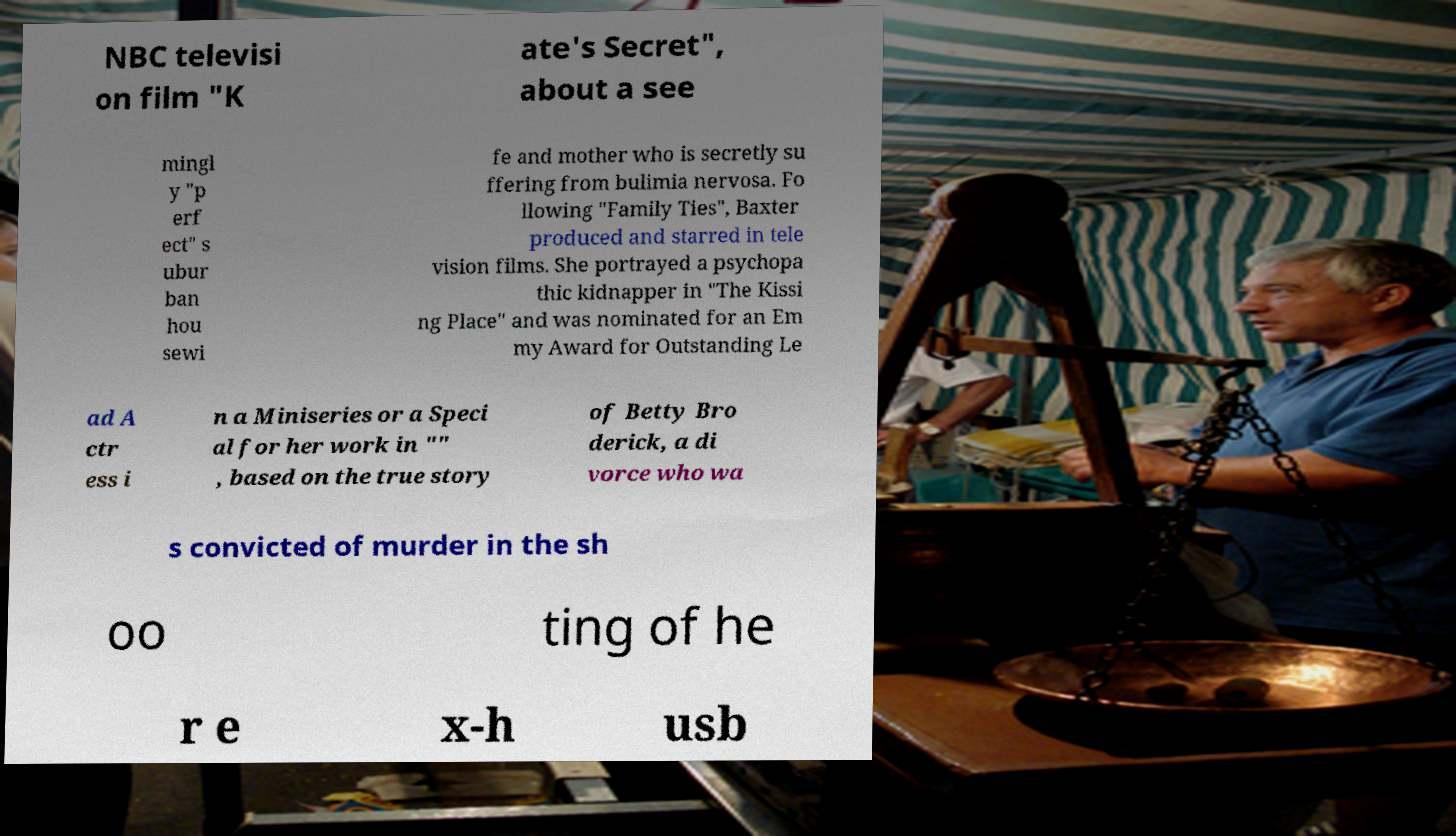I need the written content from this picture converted into text. Can you do that? NBC televisi on film "K ate's Secret", about a see mingl y "p erf ect" s ubur ban hou sewi fe and mother who is secretly su ffering from bulimia nervosa. Fo llowing "Family Ties", Baxter produced and starred in tele vision films. She portrayed a psychopa thic kidnapper in "The Kissi ng Place" and was nominated for an Em my Award for Outstanding Le ad A ctr ess i n a Miniseries or a Speci al for her work in "" , based on the true story of Betty Bro derick, a di vorce who wa s convicted of murder in the sh oo ting of he r e x-h usb 